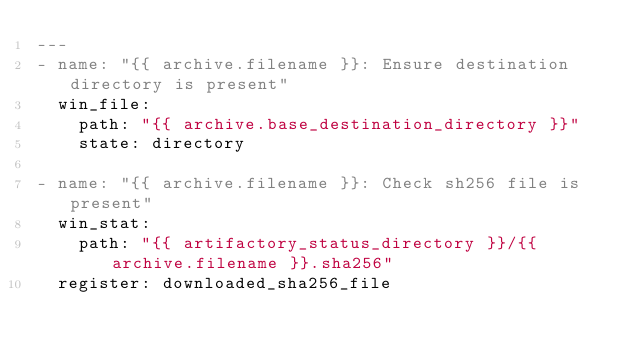Convert code to text. <code><loc_0><loc_0><loc_500><loc_500><_YAML_>---
- name: "{{ archive.filename }}: Ensure destination directory is present"
  win_file:
    path: "{{ archive.base_destination_directory }}"
    state: directory

- name: "{{ archive.filename }}: Check sh256 file is present"
  win_stat:
    path: "{{ artifactory_status_directory }}/{{ archive.filename }}.sha256"
  register: downloaded_sha256_file
</code> 